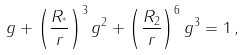<formula> <loc_0><loc_0><loc_500><loc_500>g + \left ( \frac { R _ { ^ { * } } } { r } \right ) ^ { 3 } g ^ { 2 } + \left ( \frac { R _ { 2 } } { r } \right ) ^ { 6 } g ^ { 3 } = 1 \, ,</formula> 